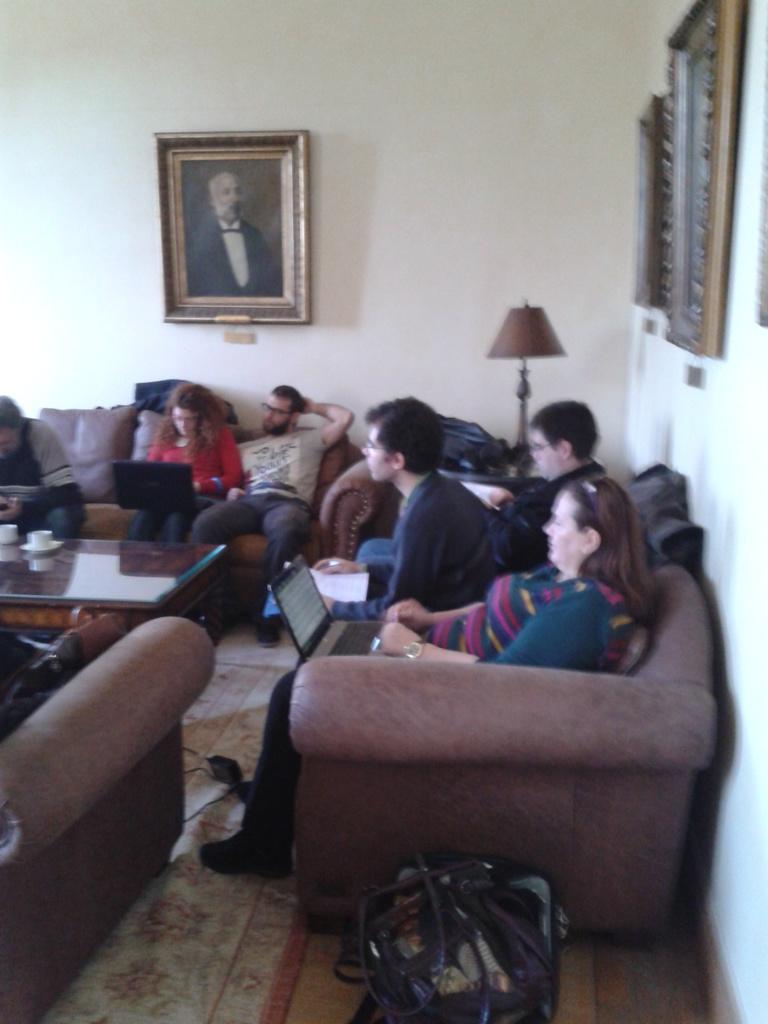Can you describe this image briefly? In this image we can see a few people who are sitting on a sofa and they are working on a laptop. This is a wooden glass table where two cups are placed on it. This is a photo frame which is fixed to a wall and this is a table lamp which is placed on this table. 